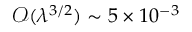<formula> <loc_0><loc_0><loc_500><loc_500>\mathcal { O } ( \lambda ^ { 3 / 2 } ) \sim 5 \times 1 0 ^ { - 3 }</formula> 